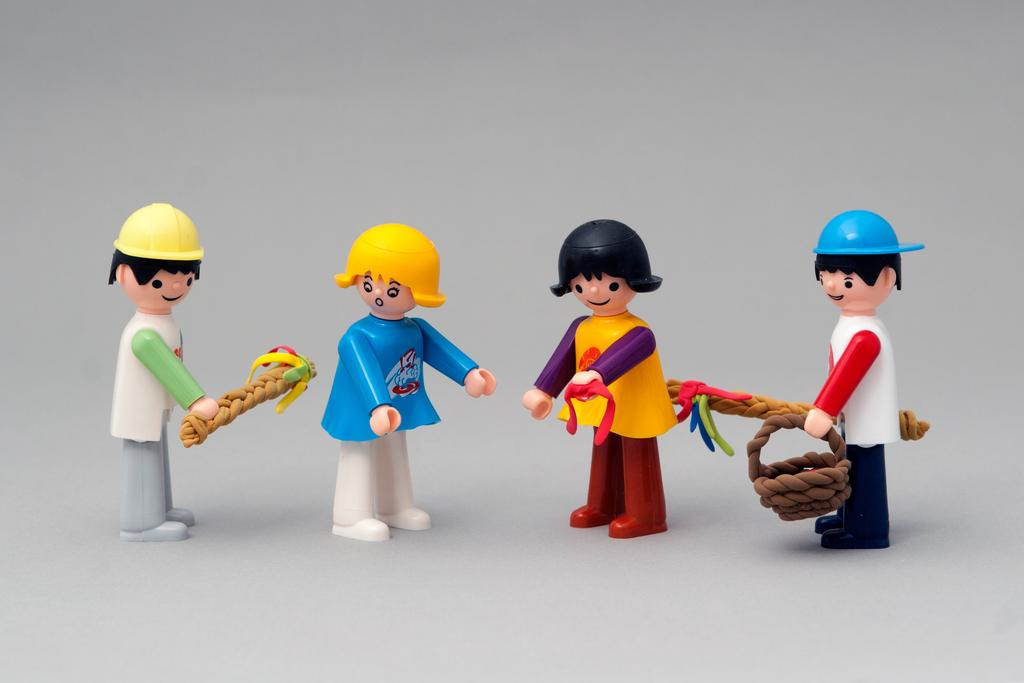What is the main subject of the image? The main subject of the image is a group of toys. What are the toys doing or holding? The toys depict persons holding objects. What is the toys standing on? The toys are standing on a white color object. What is the color of the background in the image? The background of the image is white in color. Can you tell me how much salt is being used by the toys in the image? There is no salt present in the image, as it features a group of toys holding objects. What type of work are the toys performing in the image? The toys are not performing any work in the image; they are simply depicted as persons holding objects. 